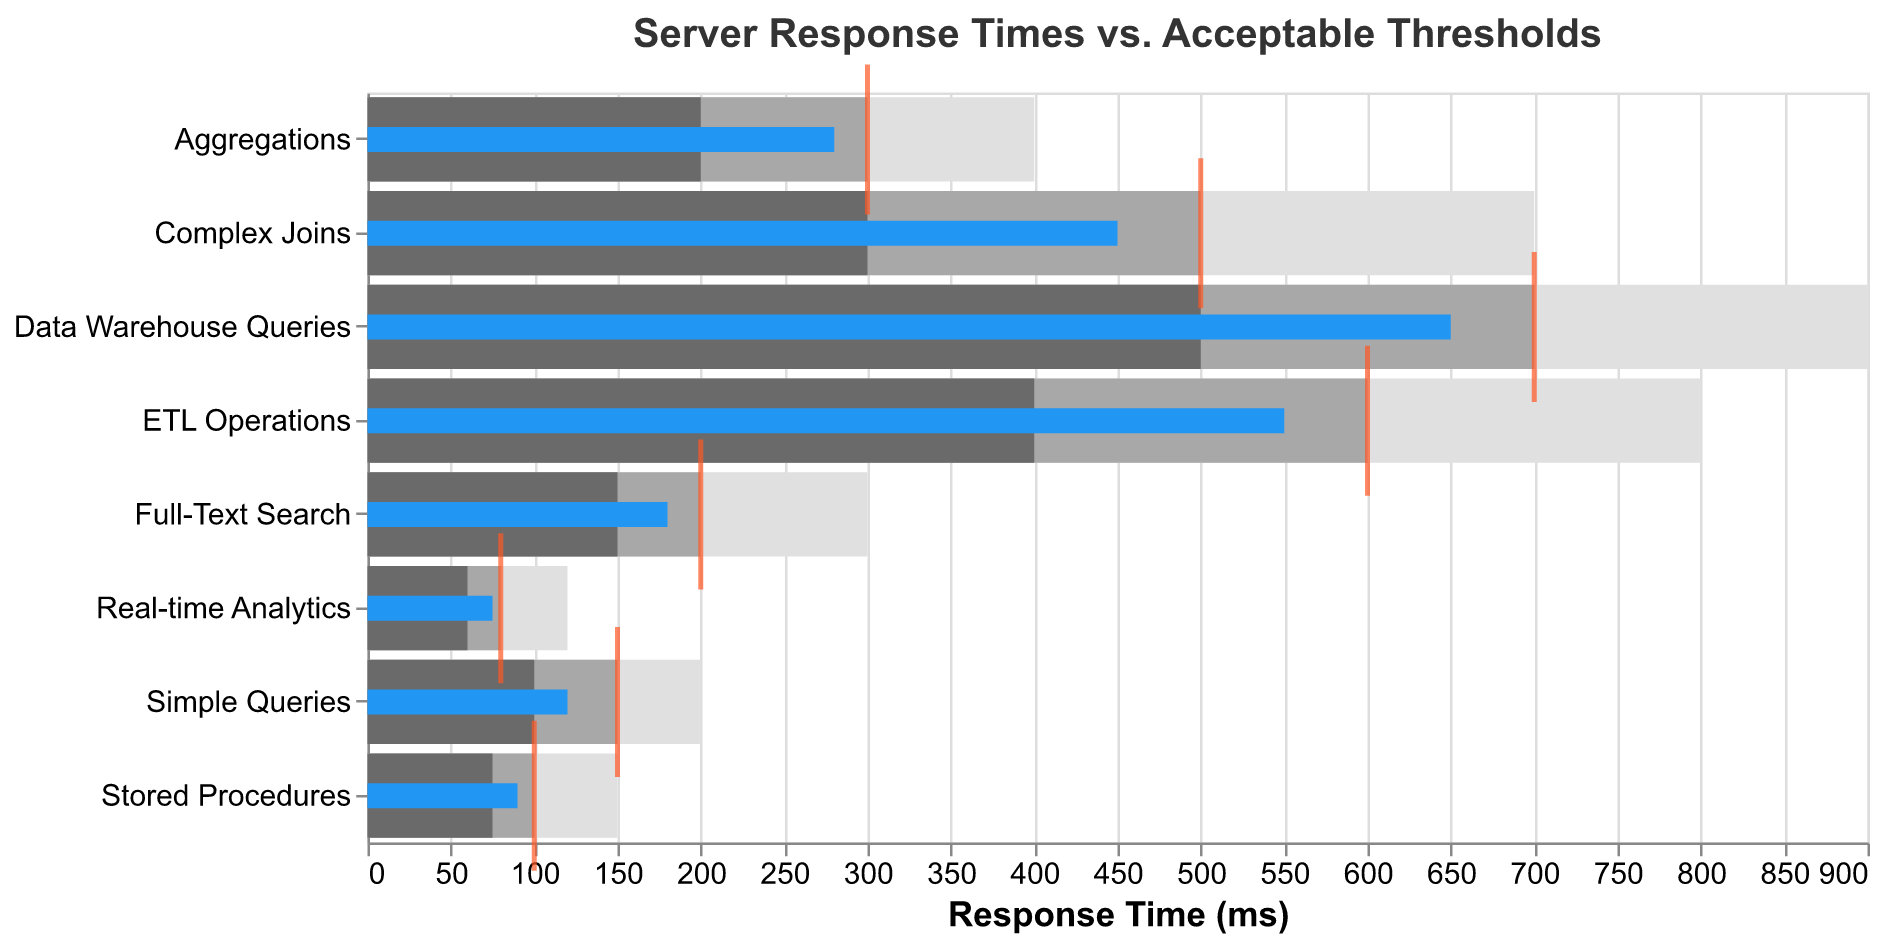What's the title of the figure? The title is displayed at the top of the figure. It reads "Server Response Times vs. Acceptable Thresholds."
Answer: Server Response Times vs. Acceptable Thresholds How many categories are shown in the figure? Count the number of unique categories listed along the y-axis in the figure. Each bar represents a category, and there are eight categories in total.
Answer: Eight What is the actual response time for ETL Operations? Locate the bar or mark labeled "Actual" for the ETL Operations row. The actual value indicated is 550 milliseconds.
Answer: 550 Which category has the lowest target response time? Compare the target response times across all categories. Real-time Analytics has the lowest target response time of 80 milliseconds.
Answer: Real-time Analytics Is the actual response time for Stored Procedures better than its satisfactory threshold? Compare the actual response time and satisfactory threshold for Stored Procedures. The actual response time is 90 milliseconds, which is lower than the satisfactory threshold of 100 milliseconds, indicating that it is indeed better.
Answer: Yes Which category exceeds its target response time by the largest margin? Calculate the difference between actual and target response times for all categories. ETL Operations exceeds its target by the largest margin (550 - 600 = -50 milliseconds).
Answer: ETL Operations Which category is performing the worst in terms of the difference between actual and poor thresholds? Calculate the difference between actual and poor thresholds for all categories. Real-time Analytics has the smallest difference, indicating the worst performance (75 - 120 = -45 milliseconds).
Answer: Real-time Analytics What is the average target response time for all categories? Add all the target response times and divide by the number of categories. (150 + 500 + 300 + 200 + 100 + 700 + 80 + 600) / 8 = 2625 / 8 = 328.125 milliseconds.
Answer: 328.125 Which category has the biggest difference between its good and poor thresholds? Calculate the difference between good and poor thresholds for all categories. Data Warehouse Queries has the biggest difference (900 - 500 = 400 milliseconds).
Answer: Data Warehouse Queries How does the actual response time for Complex Joins compare to Full-Text Search? Compare the actual response times of Complex Joins and Full-Text Search. Complex Joins is 450 milliseconds while Full-Text Search is 180 milliseconds. Complex Joins takes longer to respond.
Answer: Complex Joins is longer 